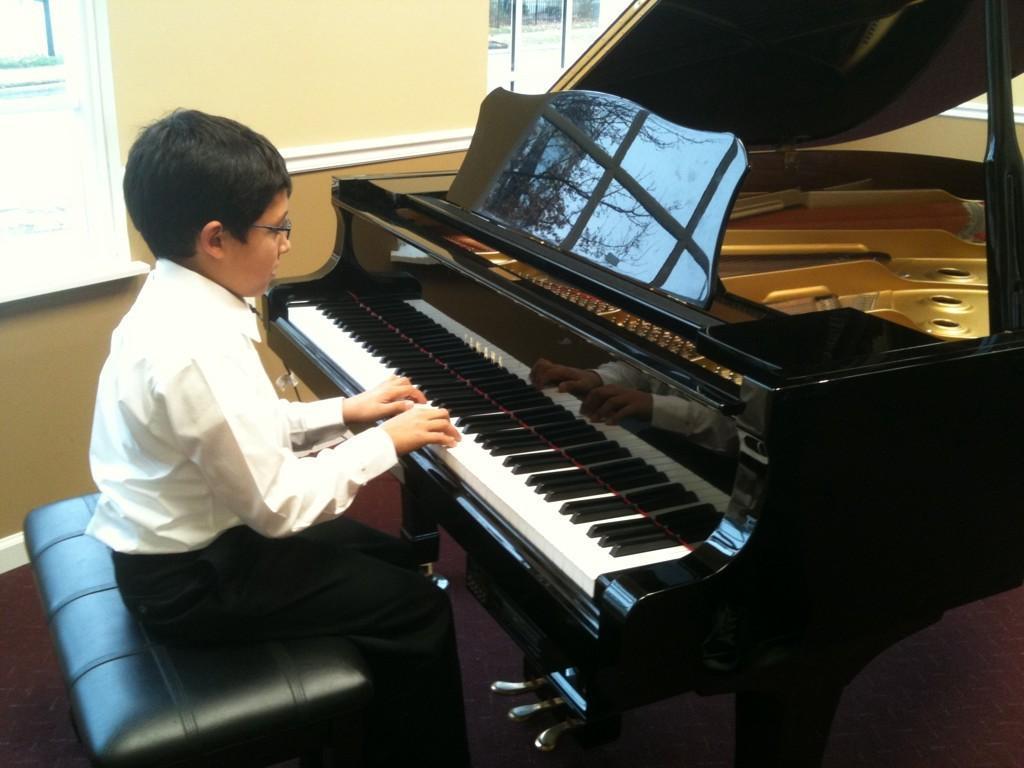How would you summarize this image in a sentence or two? In the picture we can see a child playing piano which is in front of him ,he is sitting on the table,near to the child there was wall with the window. 